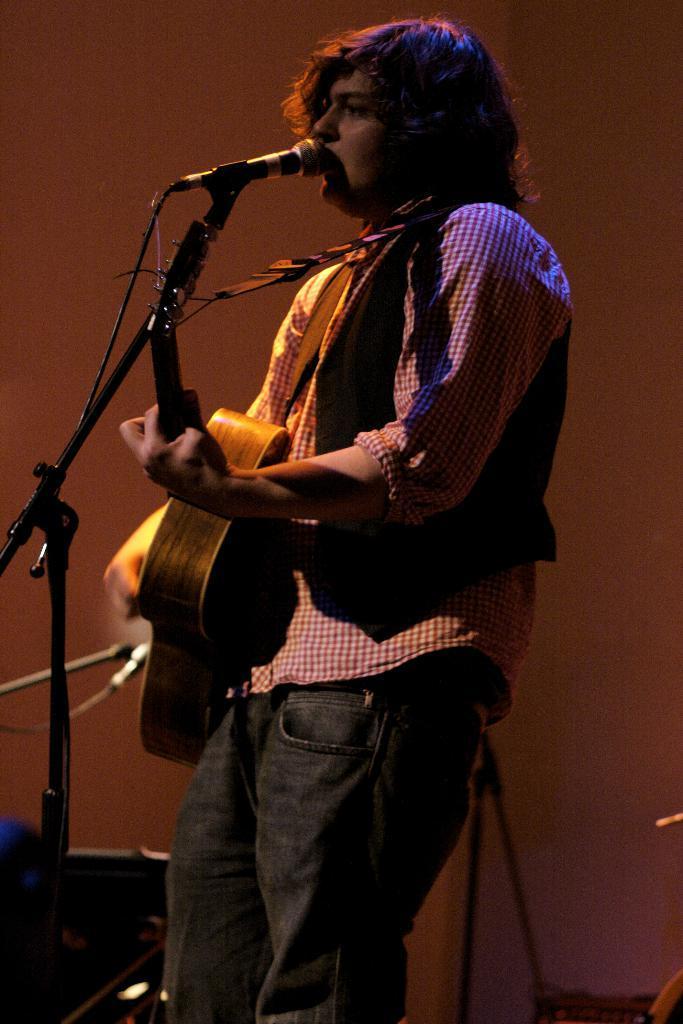Describe this image in one or two sentences. A man is standing and holding a guitar and singing through microphone. 